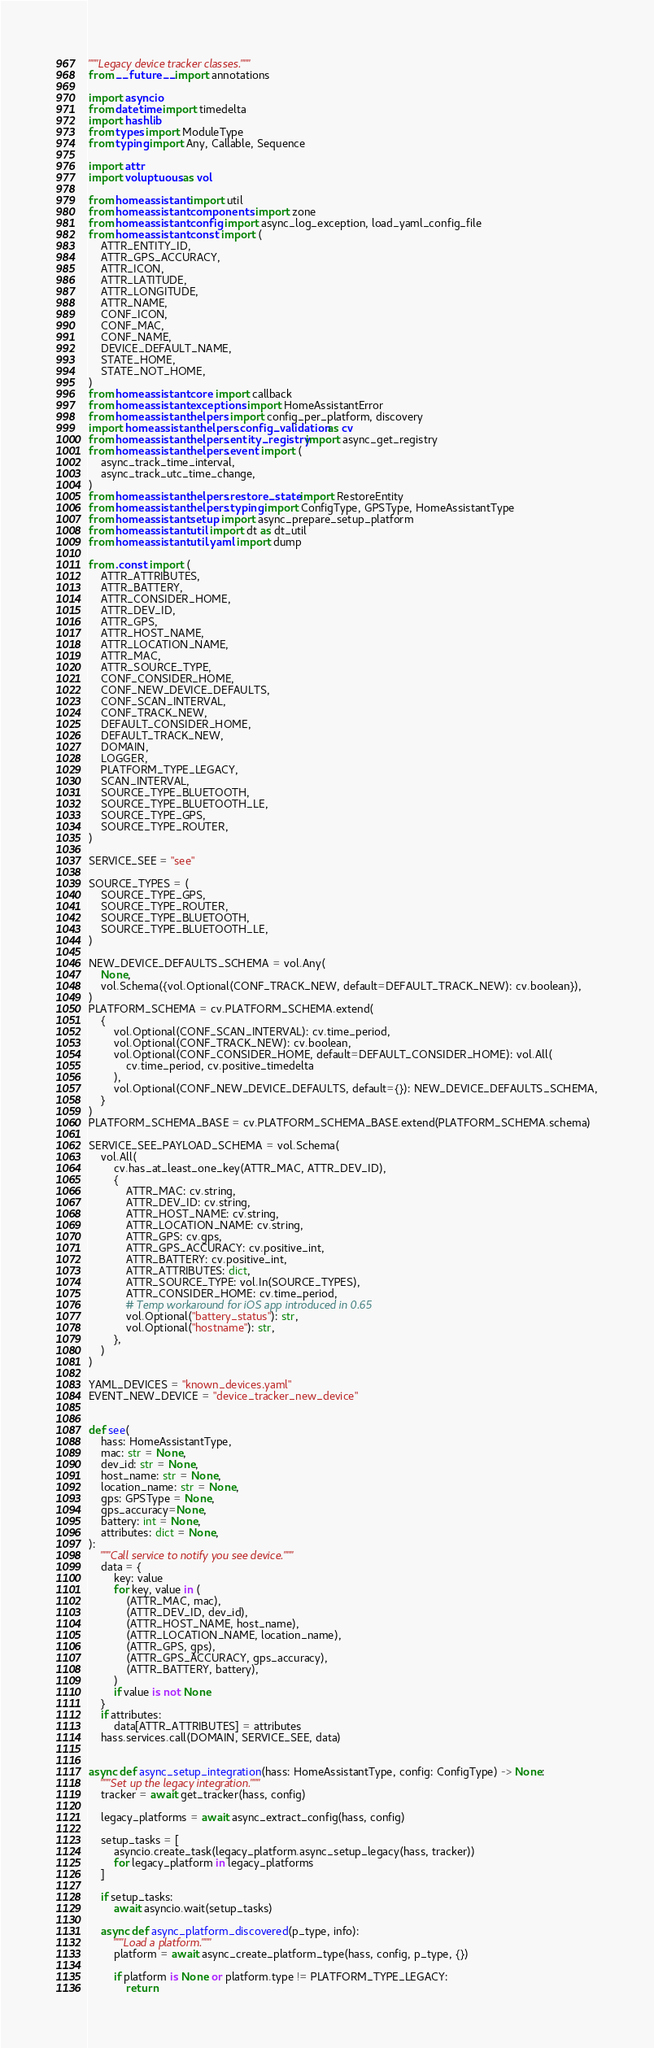<code> <loc_0><loc_0><loc_500><loc_500><_Python_>"""Legacy device tracker classes."""
from __future__ import annotations

import asyncio
from datetime import timedelta
import hashlib
from types import ModuleType
from typing import Any, Callable, Sequence

import attr
import voluptuous as vol

from homeassistant import util
from homeassistant.components import zone
from homeassistant.config import async_log_exception, load_yaml_config_file
from homeassistant.const import (
    ATTR_ENTITY_ID,
    ATTR_GPS_ACCURACY,
    ATTR_ICON,
    ATTR_LATITUDE,
    ATTR_LONGITUDE,
    ATTR_NAME,
    CONF_ICON,
    CONF_MAC,
    CONF_NAME,
    DEVICE_DEFAULT_NAME,
    STATE_HOME,
    STATE_NOT_HOME,
)
from homeassistant.core import callback
from homeassistant.exceptions import HomeAssistantError
from homeassistant.helpers import config_per_platform, discovery
import homeassistant.helpers.config_validation as cv
from homeassistant.helpers.entity_registry import async_get_registry
from homeassistant.helpers.event import (
    async_track_time_interval,
    async_track_utc_time_change,
)
from homeassistant.helpers.restore_state import RestoreEntity
from homeassistant.helpers.typing import ConfigType, GPSType, HomeAssistantType
from homeassistant.setup import async_prepare_setup_platform
from homeassistant.util import dt as dt_util
from homeassistant.util.yaml import dump

from .const import (
    ATTR_ATTRIBUTES,
    ATTR_BATTERY,
    ATTR_CONSIDER_HOME,
    ATTR_DEV_ID,
    ATTR_GPS,
    ATTR_HOST_NAME,
    ATTR_LOCATION_NAME,
    ATTR_MAC,
    ATTR_SOURCE_TYPE,
    CONF_CONSIDER_HOME,
    CONF_NEW_DEVICE_DEFAULTS,
    CONF_SCAN_INTERVAL,
    CONF_TRACK_NEW,
    DEFAULT_CONSIDER_HOME,
    DEFAULT_TRACK_NEW,
    DOMAIN,
    LOGGER,
    PLATFORM_TYPE_LEGACY,
    SCAN_INTERVAL,
    SOURCE_TYPE_BLUETOOTH,
    SOURCE_TYPE_BLUETOOTH_LE,
    SOURCE_TYPE_GPS,
    SOURCE_TYPE_ROUTER,
)

SERVICE_SEE = "see"

SOURCE_TYPES = (
    SOURCE_TYPE_GPS,
    SOURCE_TYPE_ROUTER,
    SOURCE_TYPE_BLUETOOTH,
    SOURCE_TYPE_BLUETOOTH_LE,
)

NEW_DEVICE_DEFAULTS_SCHEMA = vol.Any(
    None,
    vol.Schema({vol.Optional(CONF_TRACK_NEW, default=DEFAULT_TRACK_NEW): cv.boolean}),
)
PLATFORM_SCHEMA = cv.PLATFORM_SCHEMA.extend(
    {
        vol.Optional(CONF_SCAN_INTERVAL): cv.time_period,
        vol.Optional(CONF_TRACK_NEW): cv.boolean,
        vol.Optional(CONF_CONSIDER_HOME, default=DEFAULT_CONSIDER_HOME): vol.All(
            cv.time_period, cv.positive_timedelta
        ),
        vol.Optional(CONF_NEW_DEVICE_DEFAULTS, default={}): NEW_DEVICE_DEFAULTS_SCHEMA,
    }
)
PLATFORM_SCHEMA_BASE = cv.PLATFORM_SCHEMA_BASE.extend(PLATFORM_SCHEMA.schema)

SERVICE_SEE_PAYLOAD_SCHEMA = vol.Schema(
    vol.All(
        cv.has_at_least_one_key(ATTR_MAC, ATTR_DEV_ID),
        {
            ATTR_MAC: cv.string,
            ATTR_DEV_ID: cv.string,
            ATTR_HOST_NAME: cv.string,
            ATTR_LOCATION_NAME: cv.string,
            ATTR_GPS: cv.gps,
            ATTR_GPS_ACCURACY: cv.positive_int,
            ATTR_BATTERY: cv.positive_int,
            ATTR_ATTRIBUTES: dict,
            ATTR_SOURCE_TYPE: vol.In(SOURCE_TYPES),
            ATTR_CONSIDER_HOME: cv.time_period,
            # Temp workaround for iOS app introduced in 0.65
            vol.Optional("battery_status"): str,
            vol.Optional("hostname"): str,
        },
    )
)

YAML_DEVICES = "known_devices.yaml"
EVENT_NEW_DEVICE = "device_tracker_new_device"


def see(
    hass: HomeAssistantType,
    mac: str = None,
    dev_id: str = None,
    host_name: str = None,
    location_name: str = None,
    gps: GPSType = None,
    gps_accuracy=None,
    battery: int = None,
    attributes: dict = None,
):
    """Call service to notify you see device."""
    data = {
        key: value
        for key, value in (
            (ATTR_MAC, mac),
            (ATTR_DEV_ID, dev_id),
            (ATTR_HOST_NAME, host_name),
            (ATTR_LOCATION_NAME, location_name),
            (ATTR_GPS, gps),
            (ATTR_GPS_ACCURACY, gps_accuracy),
            (ATTR_BATTERY, battery),
        )
        if value is not None
    }
    if attributes:
        data[ATTR_ATTRIBUTES] = attributes
    hass.services.call(DOMAIN, SERVICE_SEE, data)


async def async_setup_integration(hass: HomeAssistantType, config: ConfigType) -> None:
    """Set up the legacy integration."""
    tracker = await get_tracker(hass, config)

    legacy_platforms = await async_extract_config(hass, config)

    setup_tasks = [
        asyncio.create_task(legacy_platform.async_setup_legacy(hass, tracker))
        for legacy_platform in legacy_platforms
    ]

    if setup_tasks:
        await asyncio.wait(setup_tasks)

    async def async_platform_discovered(p_type, info):
        """Load a platform."""
        platform = await async_create_platform_type(hass, config, p_type, {})

        if platform is None or platform.type != PLATFORM_TYPE_LEGACY:
            return
</code> 